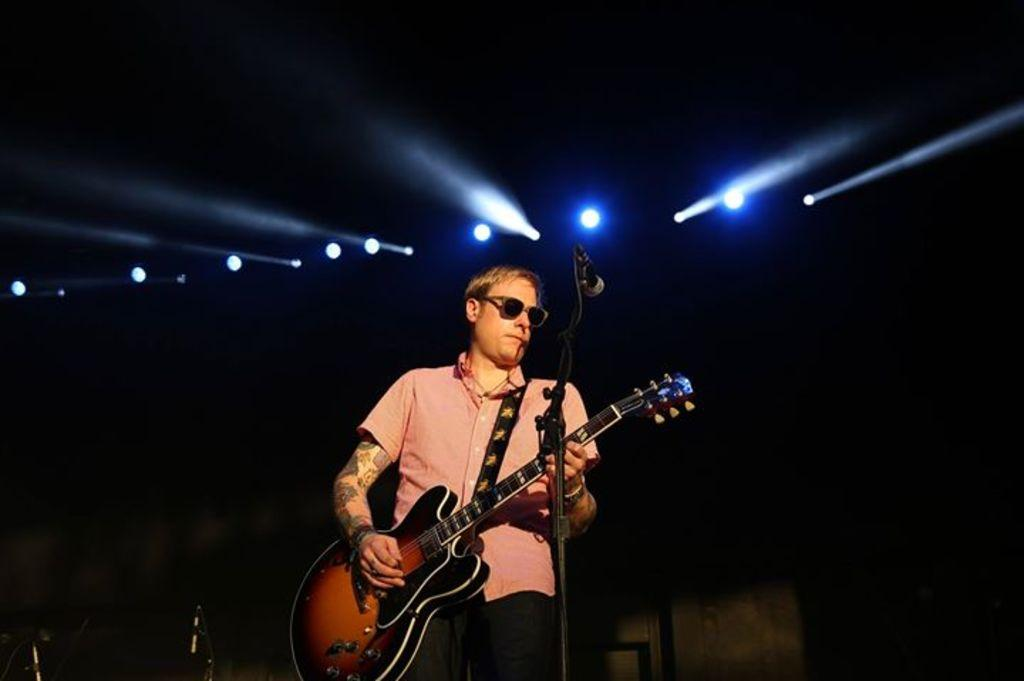Who is the main subject in the image? There is a man in the image. What is the man holding in his hand? The man is holding a guitar in his hand. What object is in front of the man that is typically used for amplifying sound? There is a microphone with a stand in front of the man. What type of machine is the man using to play baseball in the image? There is no baseball or machine present in the image; the man is holding a guitar and standing near a microphone. 